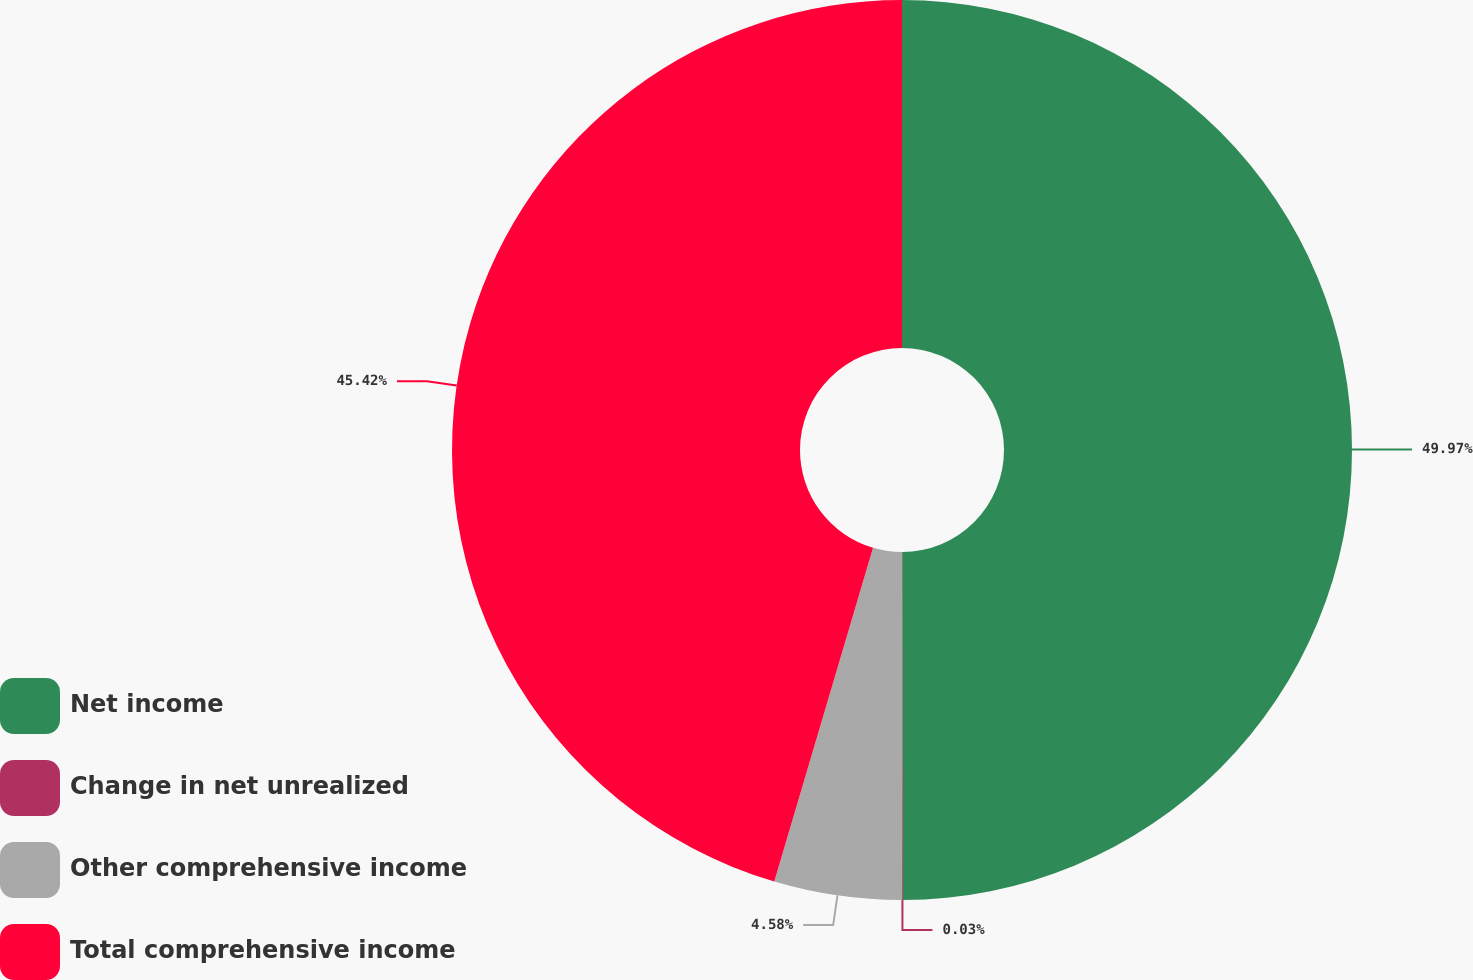Convert chart. <chart><loc_0><loc_0><loc_500><loc_500><pie_chart><fcel>Net income<fcel>Change in net unrealized<fcel>Other comprehensive income<fcel>Total comprehensive income<nl><fcel>49.97%<fcel>0.03%<fcel>4.58%<fcel>45.42%<nl></chart> 